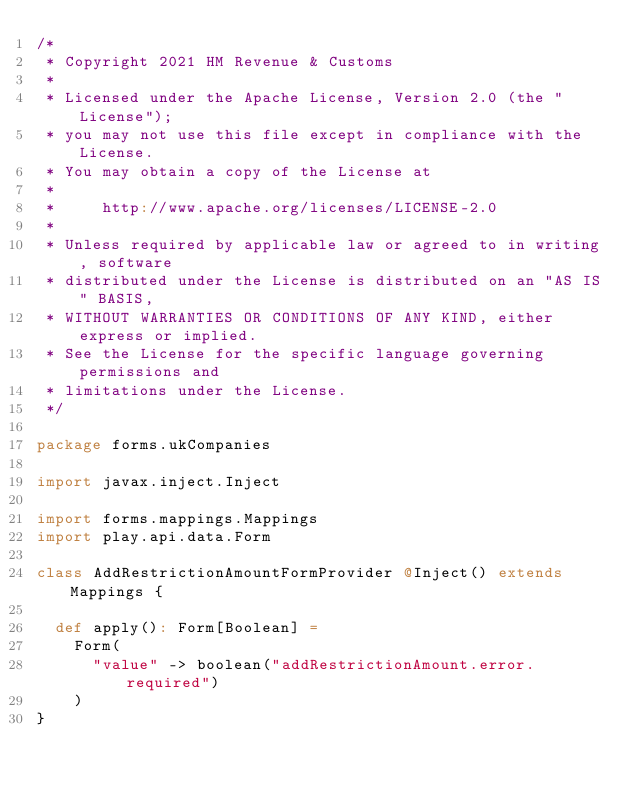Convert code to text. <code><loc_0><loc_0><loc_500><loc_500><_Scala_>/*
 * Copyright 2021 HM Revenue & Customs
 *
 * Licensed under the Apache License, Version 2.0 (the "License");
 * you may not use this file except in compliance with the License.
 * You may obtain a copy of the License at
 *
 *     http://www.apache.org/licenses/LICENSE-2.0
 *
 * Unless required by applicable law or agreed to in writing, software
 * distributed under the License is distributed on an "AS IS" BASIS,
 * WITHOUT WARRANTIES OR CONDITIONS OF ANY KIND, either express or implied.
 * See the License for the specific language governing permissions and
 * limitations under the License.
 */

package forms.ukCompanies

import javax.inject.Inject

import forms.mappings.Mappings
import play.api.data.Form

class AddRestrictionAmountFormProvider @Inject() extends Mappings {

  def apply(): Form[Boolean] =
    Form(
      "value" -> boolean("addRestrictionAmount.error.required")
    )
}
</code> 